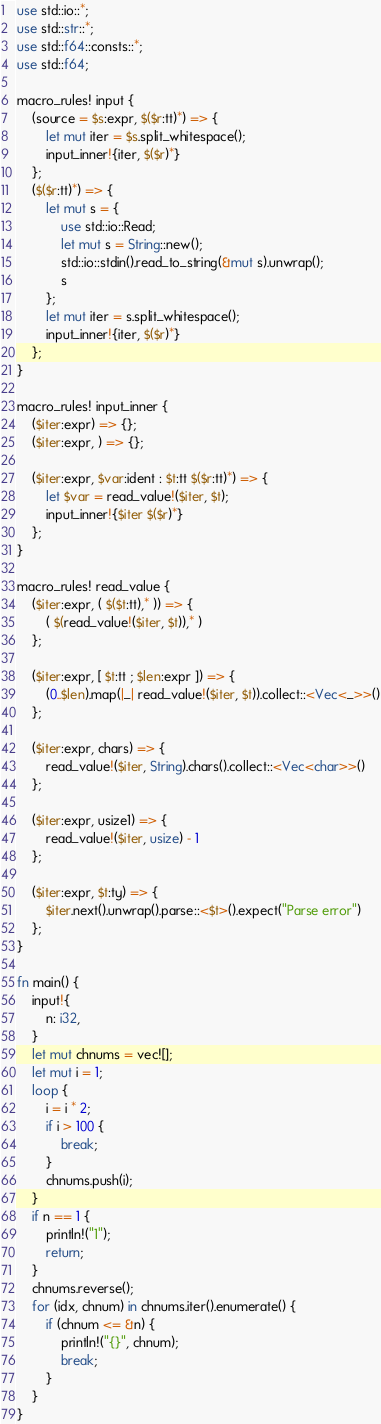<code> <loc_0><loc_0><loc_500><loc_500><_Rust_>use std::io::*;
use std::str::*;
use std::f64::consts::*;
use std::f64;

macro_rules! input {
    (source = $s:expr, $($r:tt)*) => {
        let mut iter = $s.split_whitespace();
        input_inner!{iter, $($r)*}
    };
    ($($r:tt)*) => {
        let mut s = {
            use std::io::Read;
            let mut s = String::new();
            std::io::stdin().read_to_string(&mut s).unwrap();
            s
        };
        let mut iter = s.split_whitespace();
        input_inner!{iter, $($r)*}
    };
}

macro_rules! input_inner {
    ($iter:expr) => {};
    ($iter:expr, ) => {};

    ($iter:expr, $var:ident : $t:tt $($r:tt)*) => {
        let $var = read_value!($iter, $t);
        input_inner!{$iter $($r)*}
    };
}

macro_rules! read_value {
    ($iter:expr, ( $($t:tt),* )) => {
        ( $(read_value!($iter, $t)),* )
    };

    ($iter:expr, [ $t:tt ; $len:expr ]) => {
        (0..$len).map(|_| read_value!($iter, $t)).collect::<Vec<_>>()
    };

    ($iter:expr, chars) => {
        read_value!($iter, String).chars().collect::<Vec<char>>()
    };

    ($iter:expr, usize1) => {
        read_value!($iter, usize) - 1
    };

    ($iter:expr, $t:ty) => {
        $iter.next().unwrap().parse::<$t>().expect("Parse error")
    };
}

fn main() {
    input!{
        n: i32,
    }
    let mut chnums = vec![];
    let mut i = 1;
    loop {
        i = i * 2;
        if i > 100 {
            break;
        }
        chnums.push(i);
    }
    if n == 1 {
        println!("1");
        return;
    }
    chnums.reverse();
    for (idx, chnum) in chnums.iter().enumerate() {
        if (chnum <= &n) {
            println!("{}", chnum);
            break;
        }
    }
}</code> 